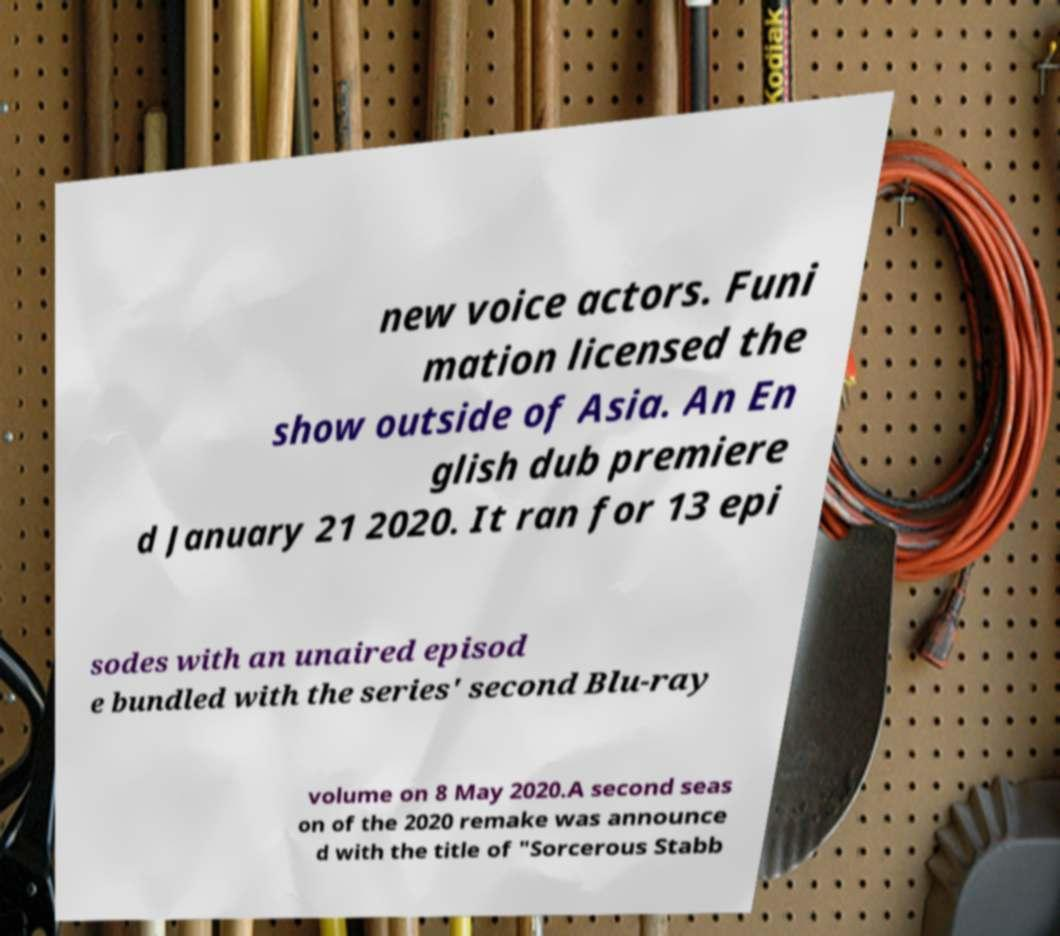What messages or text are displayed in this image? I need them in a readable, typed format. new voice actors. Funi mation licensed the show outside of Asia. An En glish dub premiere d January 21 2020. It ran for 13 epi sodes with an unaired episod e bundled with the series' second Blu-ray volume on 8 May 2020.A second seas on of the 2020 remake was announce d with the title of "Sorcerous Stabb 